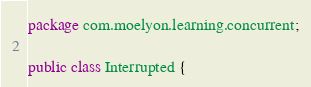<code> <loc_0><loc_0><loc_500><loc_500><_Java_>package com.moelyon.learning.concurrent;

public class Interrupted {

</code> 